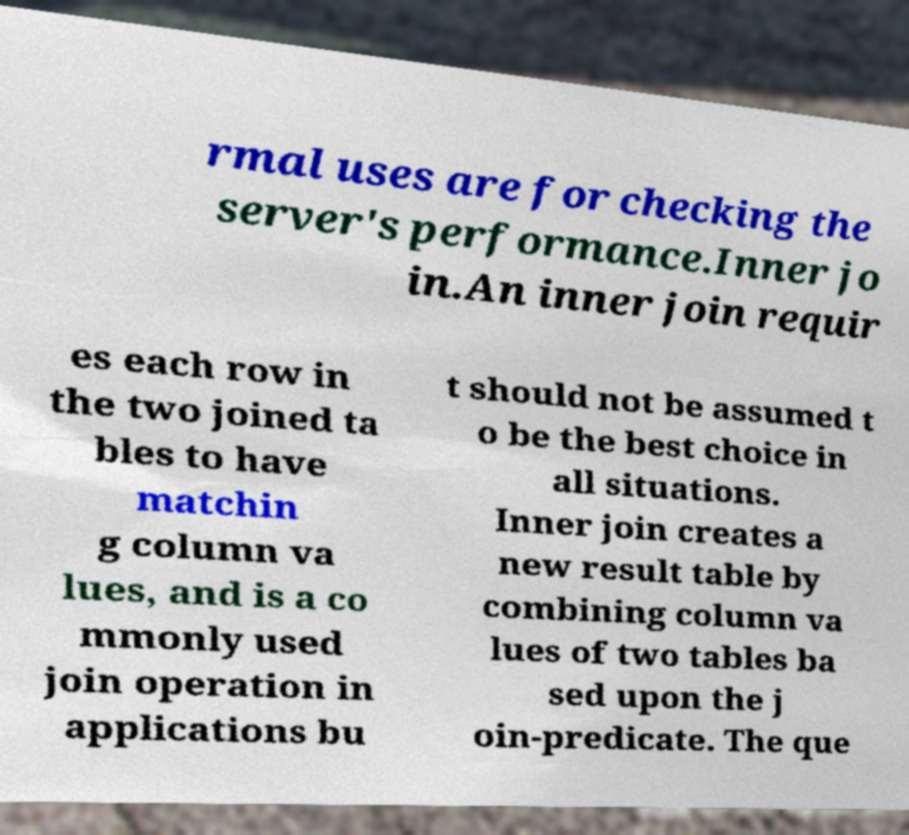Could you assist in decoding the text presented in this image and type it out clearly? rmal uses are for checking the server's performance.Inner jo in.An inner join requir es each row in the two joined ta bles to have matchin g column va lues, and is a co mmonly used join operation in applications bu t should not be assumed t o be the best choice in all situations. Inner join creates a new result table by combining column va lues of two tables ba sed upon the j oin-predicate. The que 